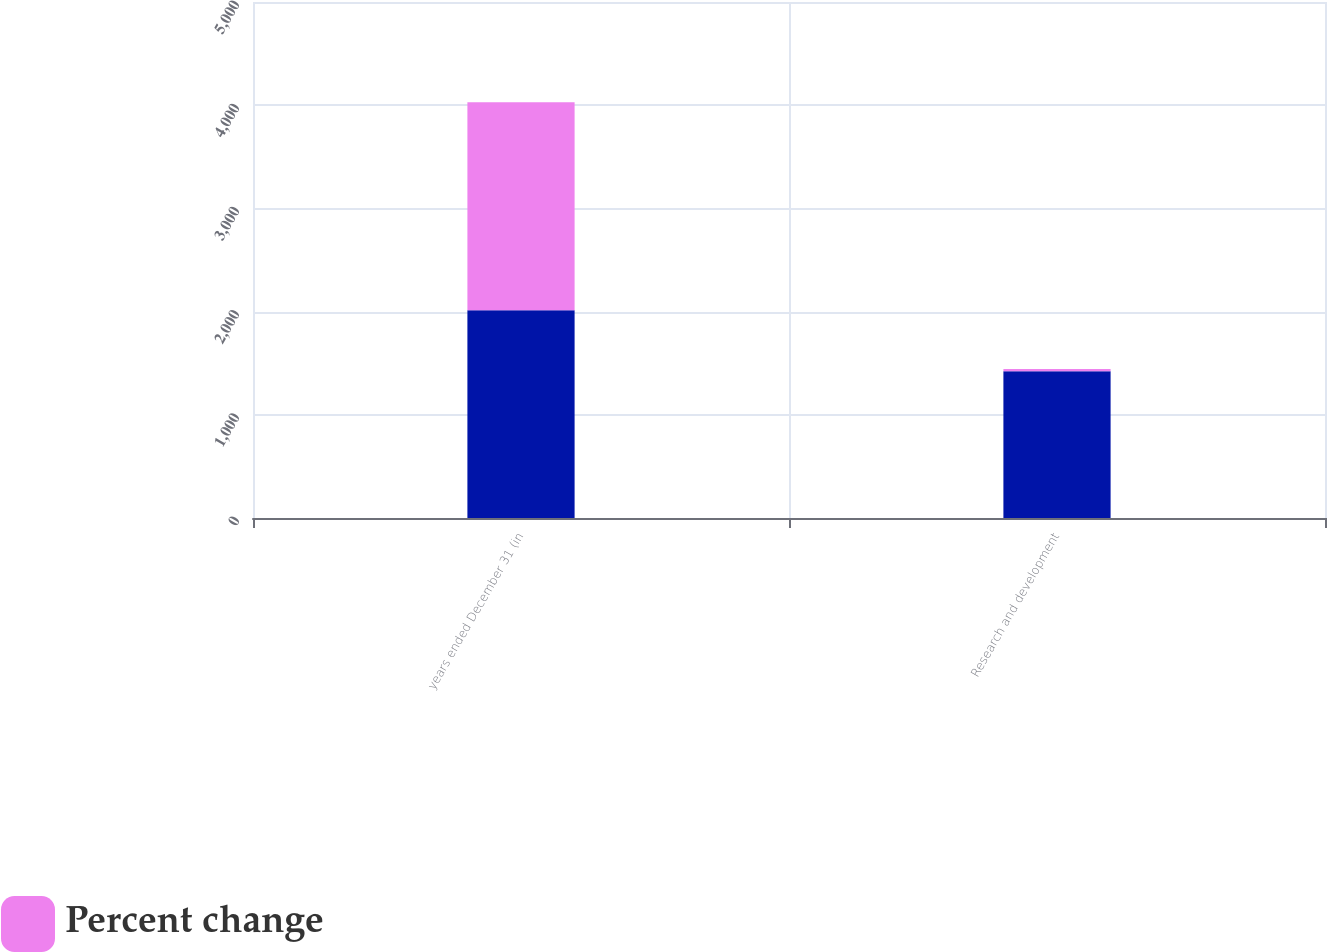<chart> <loc_0><loc_0><loc_500><loc_500><stacked_bar_chart><ecel><fcel>years ended December 31 (in<fcel>Research and development<nl><fcel>nan<fcel>2014<fcel>1421<nl><fcel>Percent change<fcel>2014<fcel>22<nl></chart> 